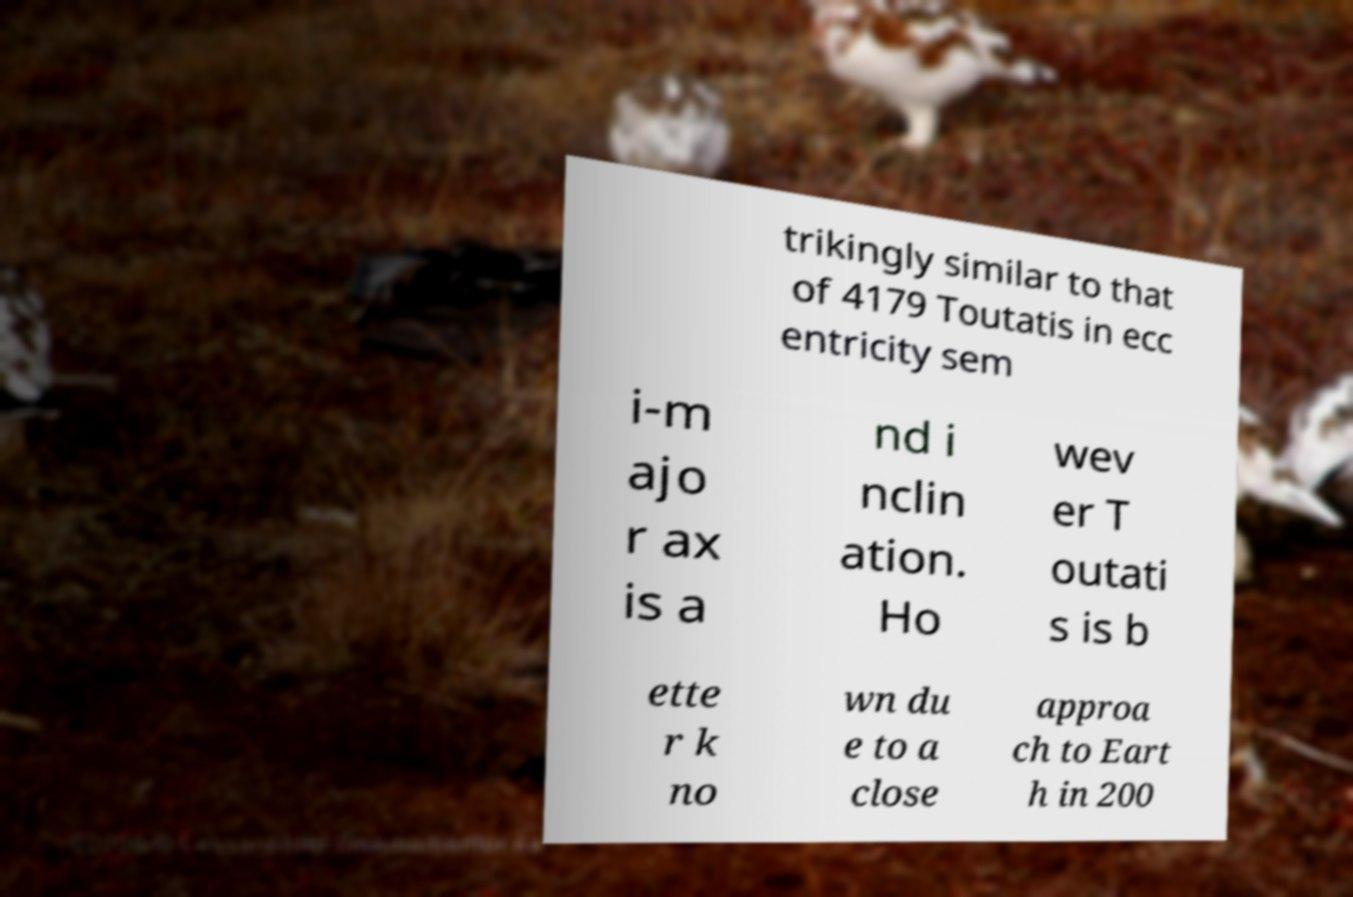Can you read and provide the text displayed in the image?This photo seems to have some interesting text. Can you extract and type it out for me? trikingly similar to that of 4179 Toutatis in ecc entricity sem i-m ajo r ax is a nd i nclin ation. Ho wev er T outati s is b ette r k no wn du e to a close approa ch to Eart h in 200 